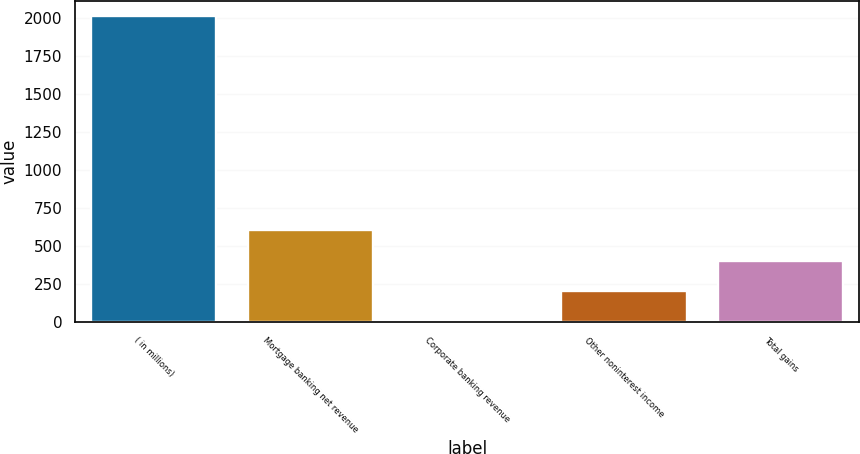<chart> <loc_0><loc_0><loc_500><loc_500><bar_chart><fcel>( in millions)<fcel>Mortgage banking net revenue<fcel>Corporate banking revenue<fcel>Other noninterest income<fcel>Total gains<nl><fcel>2011<fcel>604.7<fcel>2<fcel>202.9<fcel>403.8<nl></chart> 